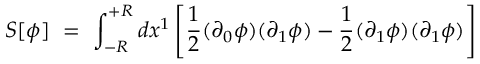Convert formula to latex. <formula><loc_0><loc_0><loc_500><loc_500>S [ \phi ] \, = \, \int _ { - R } ^ { + R } d x ^ { 1 } \left [ \frac { 1 } { 2 } ( \partial _ { 0 } \phi ) ( \partial _ { 1 } \phi ) - \frac { 1 } { 2 } ( \partial _ { 1 } \phi ) ( \partial _ { 1 } \phi ) \right ]</formula> 